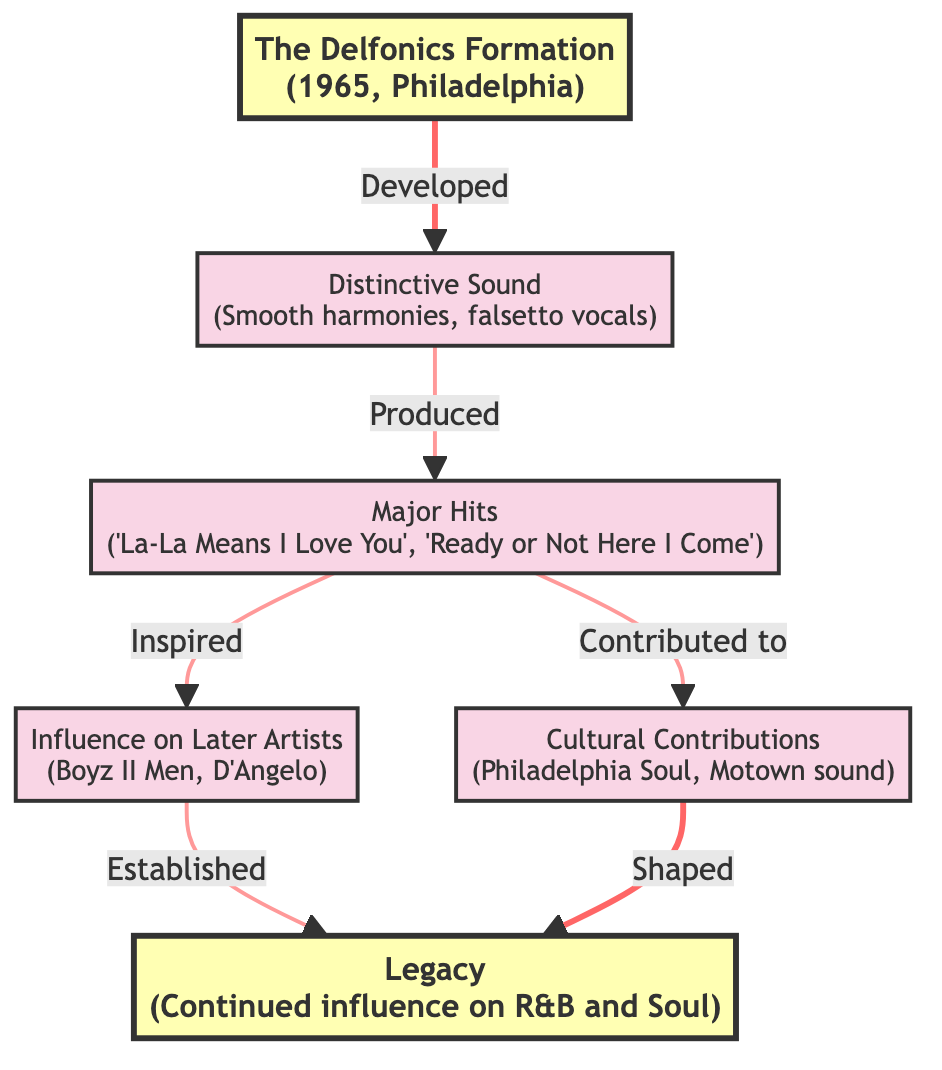What year were The Delfonics formed? The diagram indicates that The Delfonics were founded in 1965. This information is explicitly shown in the node "The Delfonics Formation."
Answer: 1965 What is a major hit by The Delfonics? The diagram lists major hits by The Delfonics, specifically mentioning "La-La (Means I Love You)" and "Ready or Not Here I Come." Both songs are cited in the "Major Hits" node.
Answer: La-La (Means I Love You) How many nodes are there in the diagram? By counting the nodes present in the flow chart, there are a total of six nodes representing different aspects of The Delfonics' impact.
Answer: 6 Who were influenced by The Delfonics? The diagram specifies that The Delfonics influenced later artists such as "Boyz II Men" and "D'Angelo," which is mentioned in the "Influence on Later Artists" node.
Answer: Boyz II Men, D'Angelo What is a cultural contribution of The Delfonics? The diagram highlights that The Delfonics elevated the "Philadelphia Soul" genre and impacted the "Motown" sound, which is detailed in the "Cultural Contributions" node.
Answer: Philadelphia Soul, Motown sound What does a major hit of The Delfonics contribute to? The diagram states that major hits produced by The Delfonics contributed to their influence on later artists, as indicated by the arrows linking "Major Hits" to "Influence on Later Artists."
Answer: Influence on Later Artists Which node is directly connected to the "Distinctive Sound"? The node "Distinctive Sound" is directly connected to the "Major Hits" node, as indicated by the arrow that specifies a production relationship between them.
Answer: Major Hits How does the legacy of The Delfonics continue? The flow chart explains that the legacy of The Delfonics continues to influence R&B and Soul music, as shown in the "Legacy" node and the connections linked back to earlier nodes like "Influence on Later Artists" and "Cultural Contributions."
Answer: Continued influence on R&B and Soul music 